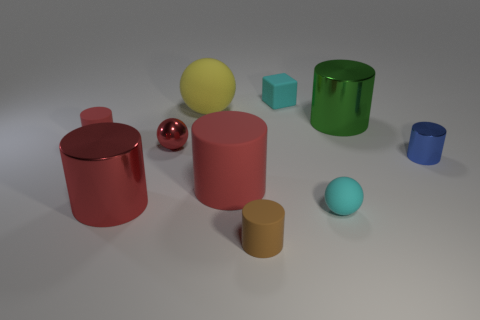Does the small rubber thing in front of the tiny rubber sphere have the same color as the small sphere that is on the right side of the brown cylinder? no 